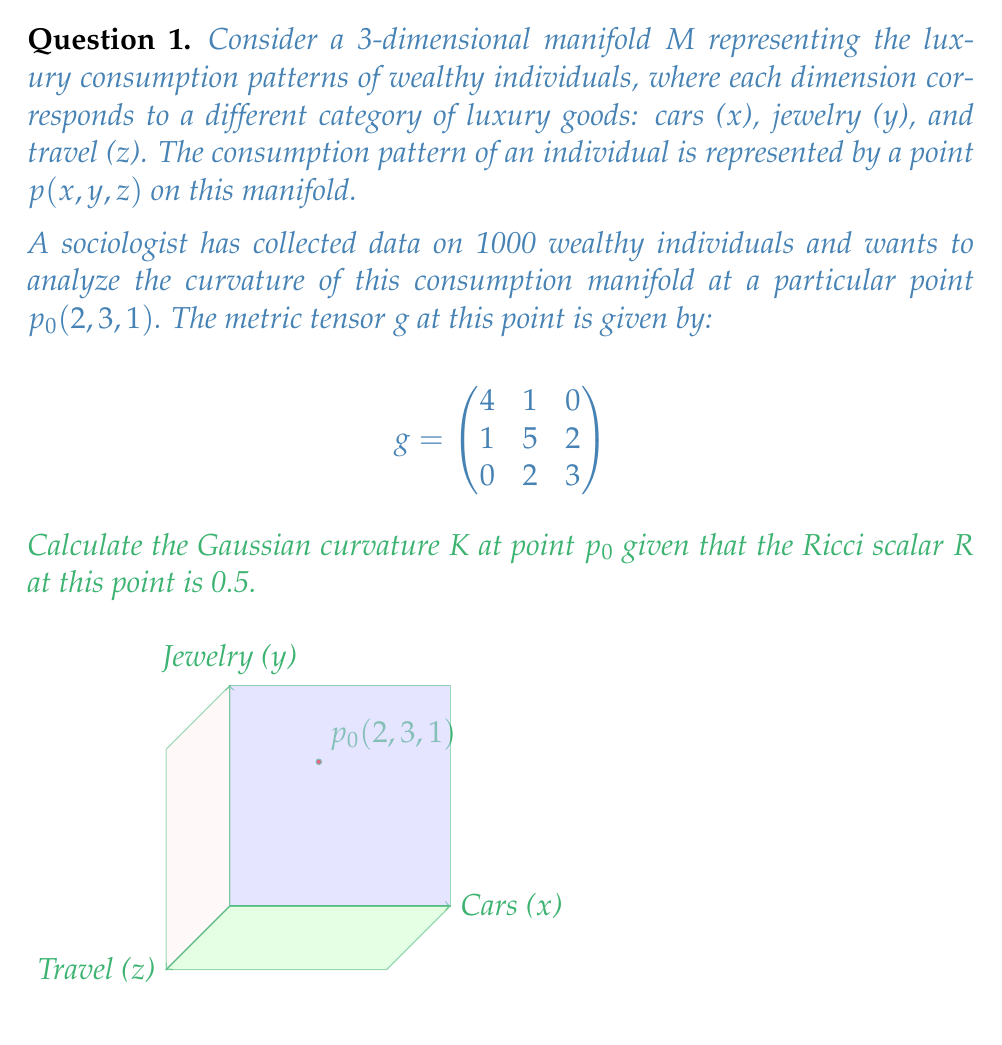Give your solution to this math problem. To solve this problem, we'll follow these steps:

1) First, recall the relationship between the Ricci scalar $R$, Gaussian curvature $K$, and the dimension $n$ of the manifold:

   $$R = n(n-1)K$$

2) In our case, we have a 3-dimensional manifold, so $n = 3$, and we're given that $R = 0.5$. Let's substitute these values:

   $$0.5 = 3(3-1)K = 6K$$

3) Now we can solve for $K$:

   $$K = \frac{0.5}{6} = \frac{1}{12}$$

4) As a verification step, we can calculate the determinant of the metric tensor $g$:

   $$\det(g) = \begin{vmatrix}
   4 & 1 & 0 \\
   1 & 5 & 2 \\
   0 & 2 & 3
   \end{vmatrix} = 4(15-4) - 1(0-6) = 44 + 6 = 50$$

   The fact that $\det(g) > 0$ confirms that our metric is indeed positive definite, which is consistent with a Riemannian manifold.

5) The positive Gaussian curvature ($K > 0$) indicates that the manifold is locally convex at point $p_0$, suggesting that luxury consumption in these three categories tends to be positively correlated for wealthy individuals near this consumption pattern.
Answer: $K = \frac{1}{12}$ 